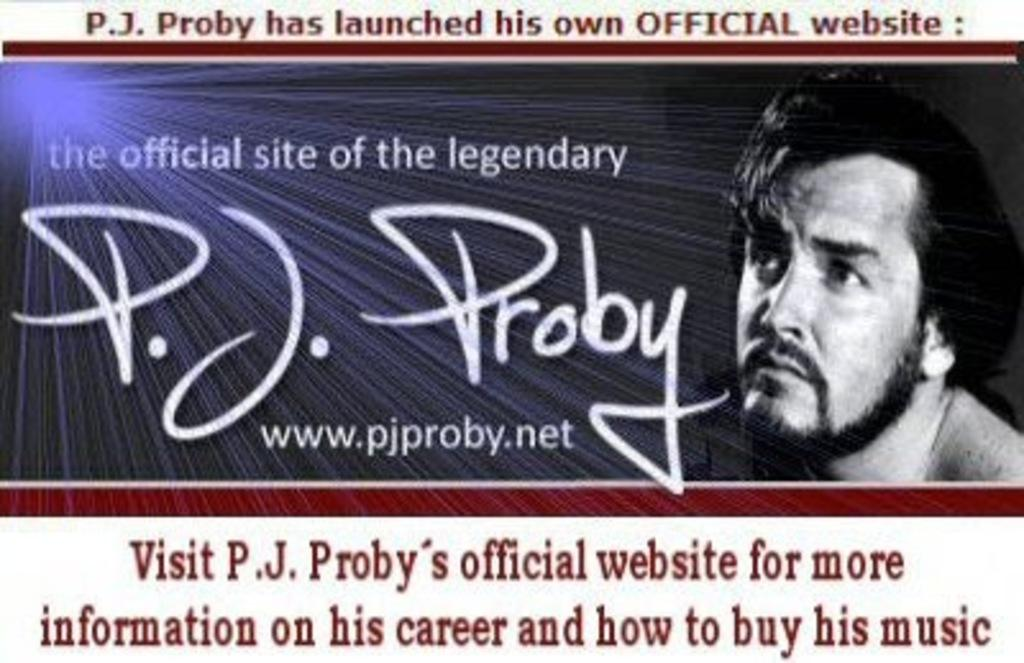What is present on the poster in the image? There is a poster in the image. What can be found on the poster besides the photo? The poster contains words. What type of image is included on the poster? The poster includes a photo of a person. What type of crush is the person in the photo experiencing in the image? There is no indication in the image of the person in the photo experiencing any type of crush. 